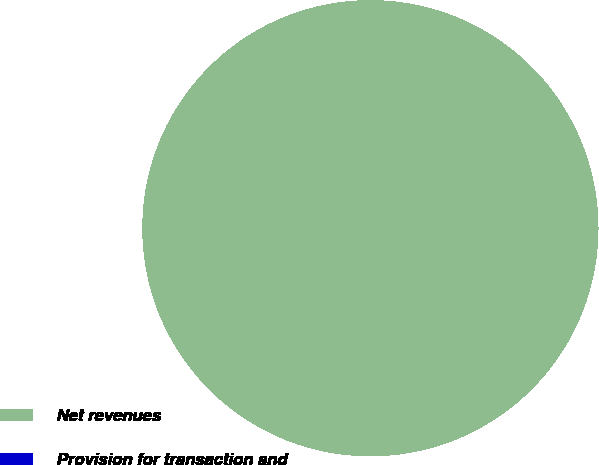Convert chart to OTSL. <chart><loc_0><loc_0><loc_500><loc_500><pie_chart><fcel>Net revenues<fcel>Provision for transaction and<nl><fcel>100.0%<fcel>0.0%<nl></chart> 